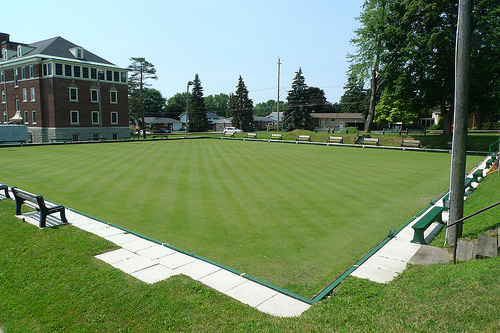<image>
Is the bench on the grass? Yes. Looking at the image, I can see the bench is positioned on top of the grass, with the grass providing support. 